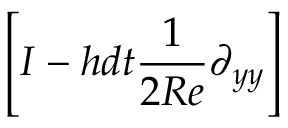<formula> <loc_0><loc_0><loc_500><loc_500>\left [ I - h d t \frac { 1 } { 2 R e } \partial _ { y y } \right ]</formula> 